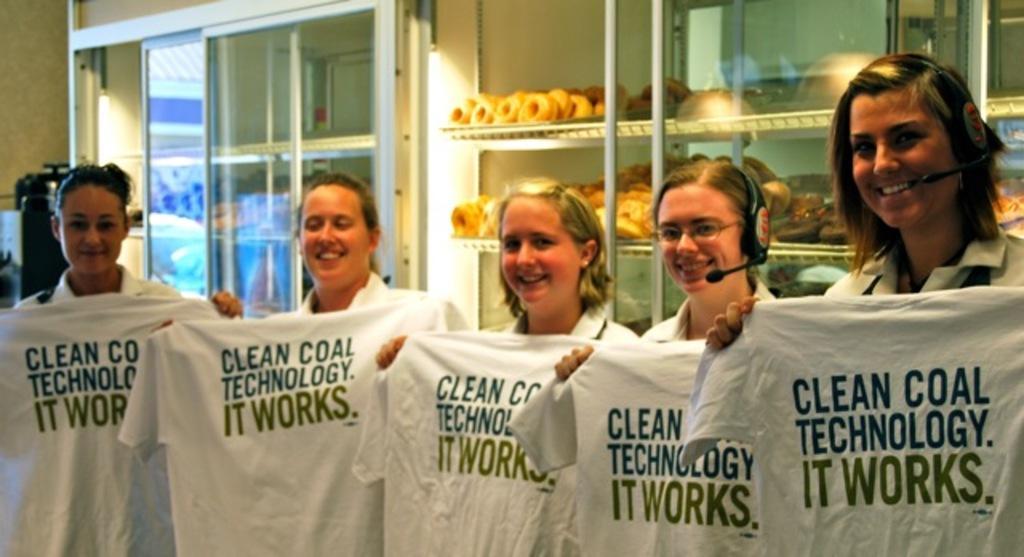Describe this image in one or two sentences. In this image in the center there are some people who are standing and they are holding some t shirts, in the background there are some cupboards. In the cupboards we could see some doughnuts and some food items, and on the left side there is a glass window and some objects. 